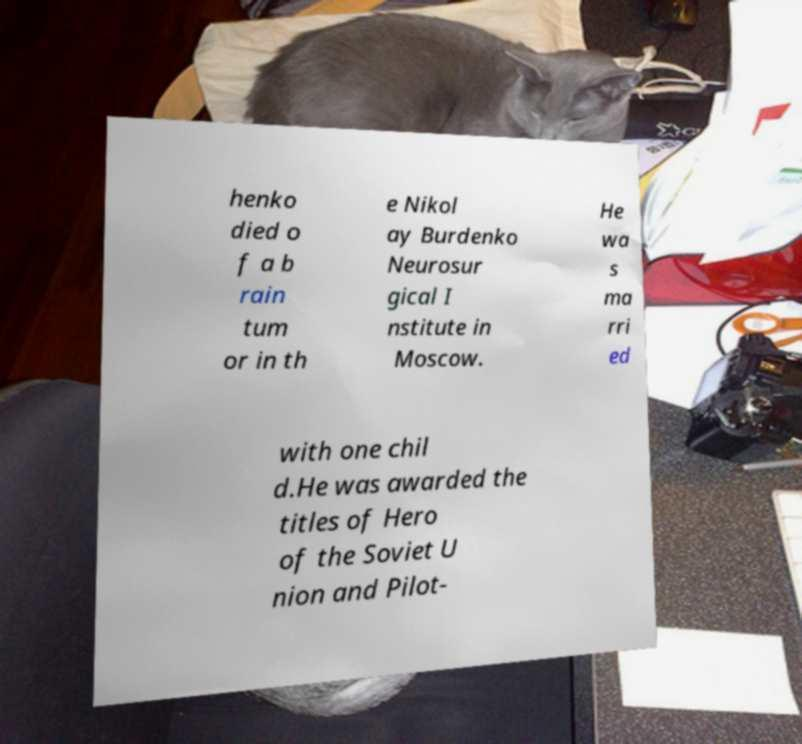Could you extract and type out the text from this image? henko died o f a b rain tum or in th e Nikol ay Burdenko Neurosur gical I nstitute in Moscow. He wa s ma rri ed with one chil d.He was awarded the titles of Hero of the Soviet U nion and Pilot- 